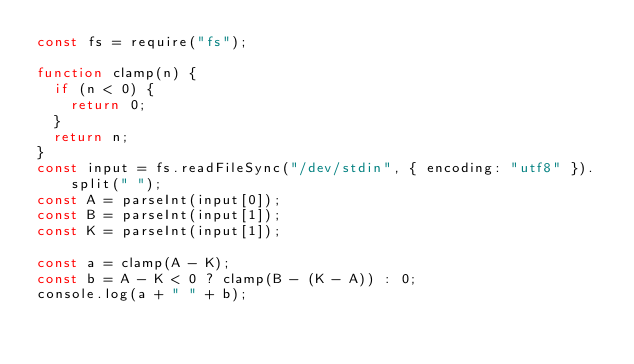<code> <loc_0><loc_0><loc_500><loc_500><_JavaScript_>const fs = require("fs");

function clamp(n) {
  if (n < 0) {
    return 0;
  }
  return n;
}
const input = fs.readFileSync("/dev/stdin", { encoding: "utf8" }).split(" ");
const A = parseInt(input[0]);
const B = parseInt(input[1]);
const K = parseInt(input[1]);

const a = clamp(A - K);
const b = A - K < 0 ? clamp(B - (K - A)) : 0;
console.log(a + " " + b);
</code> 